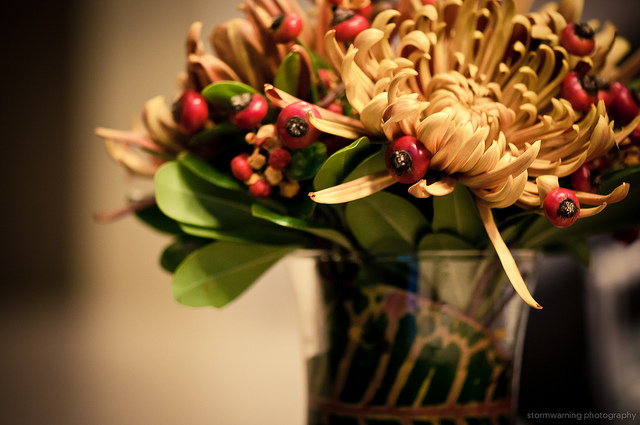<image>Do the flowers smell good? It's ambiguous if the flowers smell good as it can't be determined from the image. Do the flowers smell good? I don't know if the flowers smell good. It is possible that they do, but I cannot be certain. 